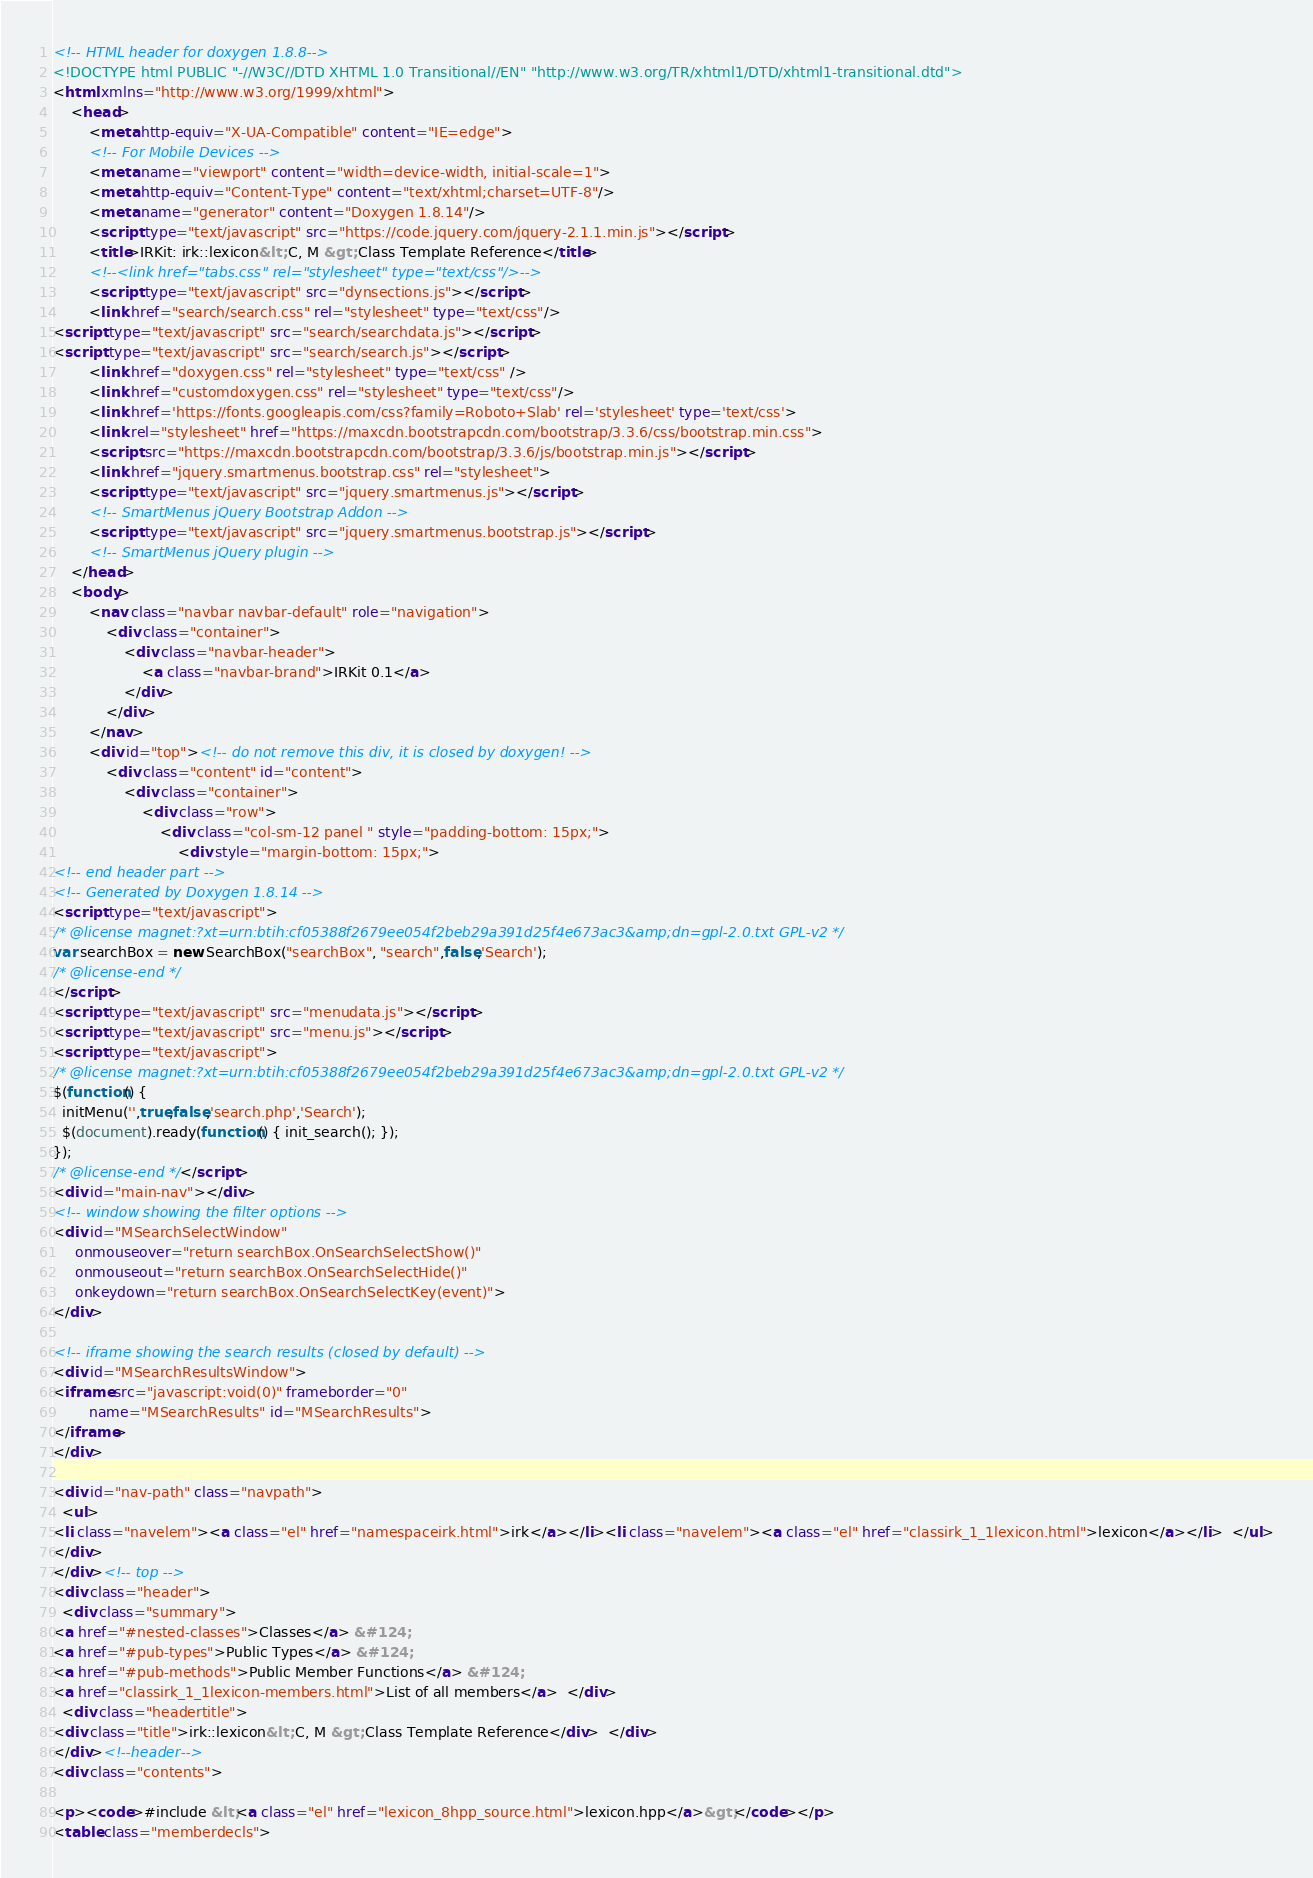Convert code to text. <code><loc_0><loc_0><loc_500><loc_500><_HTML_><!-- HTML header for doxygen 1.8.8-->
<!DOCTYPE html PUBLIC "-//W3C//DTD XHTML 1.0 Transitional//EN" "http://www.w3.org/TR/xhtml1/DTD/xhtml1-transitional.dtd">
<html xmlns="http://www.w3.org/1999/xhtml">
    <head>
        <meta http-equiv="X-UA-Compatible" content="IE=edge">
        <!-- For Mobile Devices -->
        <meta name="viewport" content="width=device-width, initial-scale=1">
        <meta http-equiv="Content-Type" content="text/xhtml;charset=UTF-8"/>
        <meta name="generator" content="Doxygen 1.8.14"/>
        <script type="text/javascript" src="https://code.jquery.com/jquery-2.1.1.min.js"></script>
        <title>IRKit: irk::lexicon&lt; C, M &gt; Class Template Reference</title>
        <!--<link href="tabs.css" rel="stylesheet" type="text/css"/>-->
        <script type="text/javascript" src="dynsections.js"></script>
        <link href="search/search.css" rel="stylesheet" type="text/css"/>
<script type="text/javascript" src="search/searchdata.js"></script>
<script type="text/javascript" src="search/search.js"></script>
        <link href="doxygen.css" rel="stylesheet" type="text/css" />
        <link href="customdoxygen.css" rel="stylesheet" type="text/css"/>
        <link href='https://fonts.googleapis.com/css?family=Roboto+Slab' rel='stylesheet' type='text/css'>
        <link rel="stylesheet" href="https://maxcdn.bootstrapcdn.com/bootstrap/3.3.6/css/bootstrap.min.css">
        <script src="https://maxcdn.bootstrapcdn.com/bootstrap/3.3.6/js/bootstrap.min.js"></script>
        <link href="jquery.smartmenus.bootstrap.css" rel="stylesheet">
        <script type="text/javascript" src="jquery.smartmenus.js"></script>
        <!-- SmartMenus jQuery Bootstrap Addon -->
        <script type="text/javascript" src="jquery.smartmenus.bootstrap.js"></script>
        <!-- SmartMenus jQuery plugin -->
    </head>
    <body>
        <nav class="navbar navbar-default" role="navigation">
            <div class="container">
                <div class="navbar-header">
                    <a class="navbar-brand">IRKit 0.1</a>
                </div>
            </div>
        </nav>
        <div id="top"><!-- do not remove this div, it is closed by doxygen! -->
            <div class="content" id="content">
                <div class="container">
                    <div class="row">
                        <div class="col-sm-12 panel " style="padding-bottom: 15px;">
                            <div style="margin-bottom: 15px;">
<!-- end header part -->
<!-- Generated by Doxygen 1.8.14 -->
<script type="text/javascript">
/* @license magnet:?xt=urn:btih:cf05388f2679ee054f2beb29a391d25f4e673ac3&amp;dn=gpl-2.0.txt GPL-v2 */
var searchBox = new SearchBox("searchBox", "search",false,'Search');
/* @license-end */
</script>
<script type="text/javascript" src="menudata.js"></script>
<script type="text/javascript" src="menu.js"></script>
<script type="text/javascript">
/* @license magnet:?xt=urn:btih:cf05388f2679ee054f2beb29a391d25f4e673ac3&amp;dn=gpl-2.0.txt GPL-v2 */
$(function() {
  initMenu('',true,false,'search.php','Search');
  $(document).ready(function() { init_search(); });
});
/* @license-end */</script>
<div id="main-nav"></div>
<!-- window showing the filter options -->
<div id="MSearchSelectWindow"
     onmouseover="return searchBox.OnSearchSelectShow()"
     onmouseout="return searchBox.OnSearchSelectHide()"
     onkeydown="return searchBox.OnSearchSelectKey(event)">
</div>

<!-- iframe showing the search results (closed by default) -->
<div id="MSearchResultsWindow">
<iframe src="javascript:void(0)" frameborder="0" 
        name="MSearchResults" id="MSearchResults">
</iframe>
</div>

<div id="nav-path" class="navpath">
  <ul>
<li class="navelem"><a class="el" href="namespaceirk.html">irk</a></li><li class="navelem"><a class="el" href="classirk_1_1lexicon.html">lexicon</a></li>  </ul>
</div>
</div><!-- top -->
<div class="header">
  <div class="summary">
<a href="#nested-classes">Classes</a> &#124;
<a href="#pub-types">Public Types</a> &#124;
<a href="#pub-methods">Public Member Functions</a> &#124;
<a href="classirk_1_1lexicon-members.html">List of all members</a>  </div>
  <div class="headertitle">
<div class="title">irk::lexicon&lt; C, M &gt; Class Template Reference</div>  </div>
</div><!--header-->
<div class="contents">

<p><code>#include &lt;<a class="el" href="lexicon_8hpp_source.html">lexicon.hpp</a>&gt;</code></p>
<table class="memberdecls"></code> 